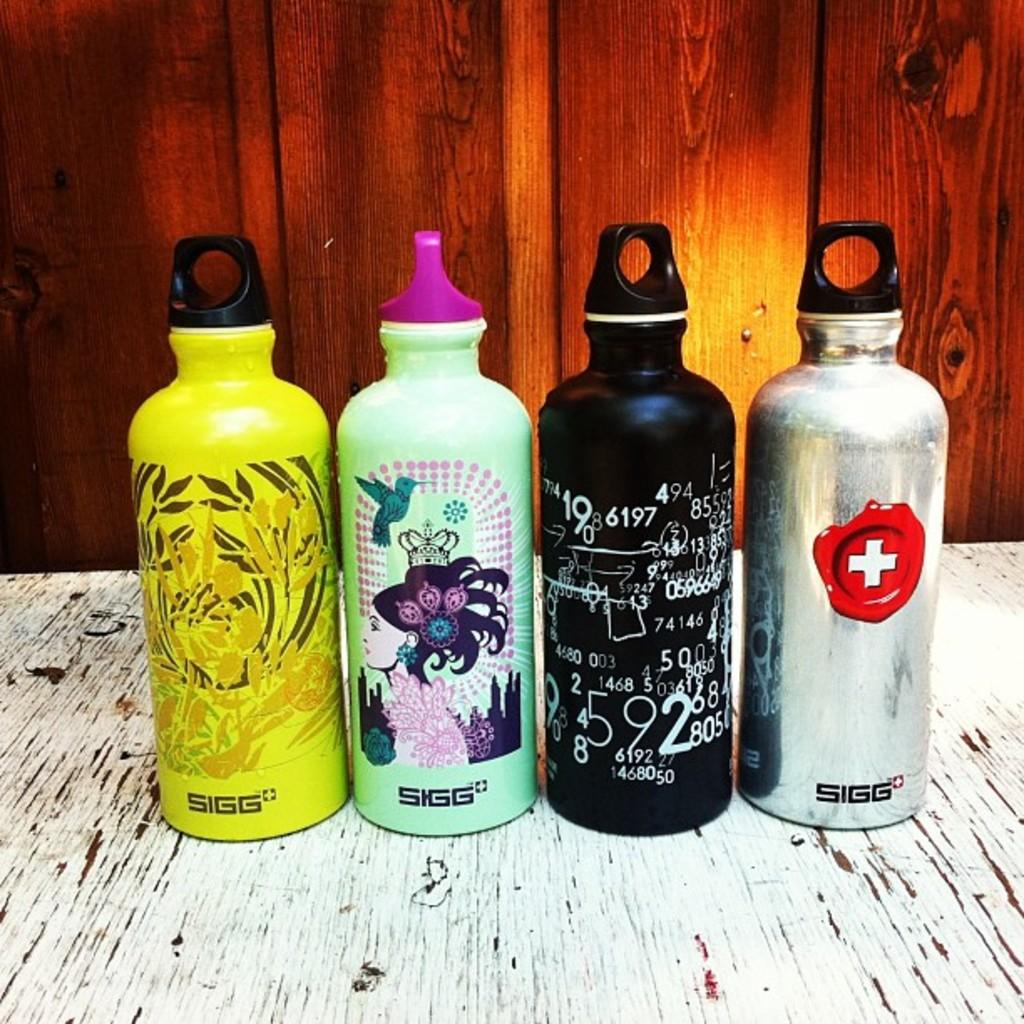What is one of the numbers on the black water bottle?
Provide a succinct answer. 9. 